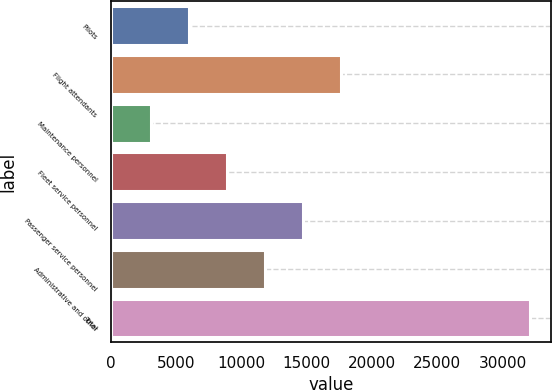Convert chart to OTSL. <chart><loc_0><loc_0><loc_500><loc_500><bar_chart><fcel>Pilots<fcel>Flight attendants<fcel>Maintenance personnel<fcel>Fleet service personnel<fcel>Passenger service personnel<fcel>Administrative and other<fcel>Total<nl><fcel>6000<fcel>17600<fcel>3100<fcel>8900<fcel>14700<fcel>11800<fcel>32100<nl></chart> 